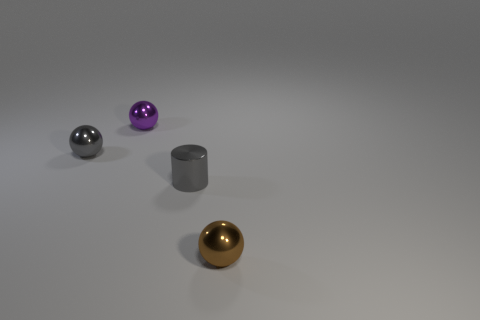Add 4 tiny metal objects. How many objects exist? 8 Subtract all cylinders. How many objects are left? 3 Add 2 brown shiny objects. How many brown shiny objects exist? 3 Subtract 0 purple cubes. How many objects are left? 4 Subtract all balls. Subtract all tiny gray cylinders. How many objects are left? 0 Add 2 gray metallic cylinders. How many gray metallic cylinders are left? 3 